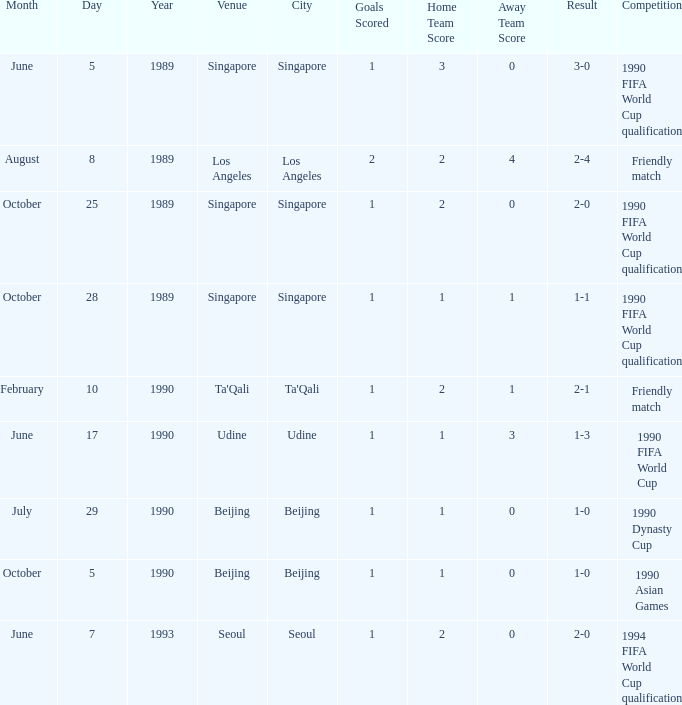What is the score of the match on July 29, 1990? 1 goal. Could you parse the entire table as a dict? {'header': ['Month', 'Day', 'Year', 'Venue', 'City', 'Goals Scored', 'Home Team Score', 'Away Team Score', 'Result', 'Competition'], 'rows': [['June', '5', '1989', 'Singapore', 'Singapore', '1', '3', '0', '3-0', '1990 FIFA World Cup qualification'], ['August', '8', '1989', 'Los Angeles', 'Los Angeles', '2', '2', '4', '2-4', 'Friendly match'], ['October', '25', '1989', 'Singapore', 'Singapore', '1', '2', '0', '2-0', '1990 FIFA World Cup qualification'], ['October', '28', '1989', 'Singapore', 'Singapore', '1', '1', '1', '1-1', '1990 FIFA World Cup qualification'], ['February', '10', '1990', "Ta'Qali", "Ta'Qali", '1', '2', '1', '2-1', 'Friendly match'], ['June', '17', '1990', 'Udine', 'Udine', '1', '1', '3', '1-3', '1990 FIFA World Cup'], ['July', '29', '1990', 'Beijing', 'Beijing', '1', '1', '0', '1-0', '1990 Dynasty Cup'], ['October', '5', '1990', 'Beijing', 'Beijing', '1', '1', '0', '1-0', '1990 Asian Games'], ['June', '7', '1993', 'Seoul', 'Seoul', '1', '2', '0', '2-0', '1994 FIFA World Cup qualification']]} 